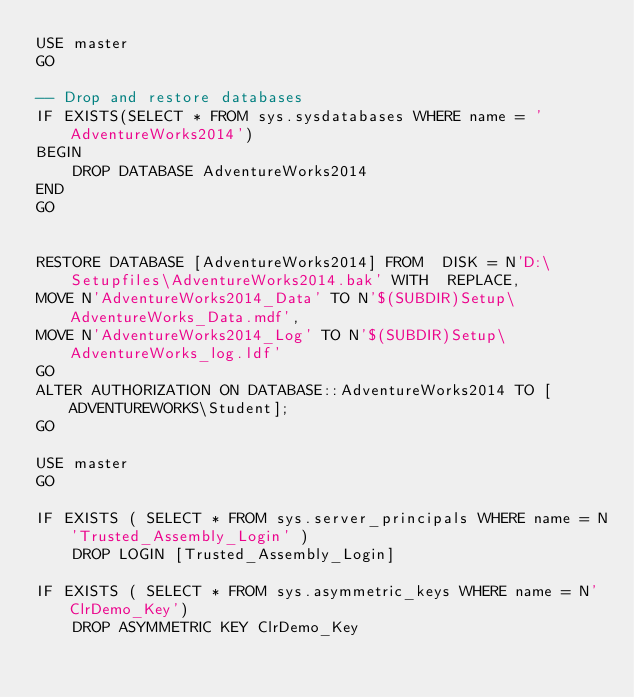Convert code to text. <code><loc_0><loc_0><loc_500><loc_500><_SQL_>USE master
GO

-- Drop and restore databases
IF EXISTS(SELECT * FROM sys.sysdatabases WHERE name = 'AdventureWorks2014')
BEGIN
	DROP DATABASE AdventureWorks2014
END
GO


RESTORE DATABASE [AdventureWorks2014] FROM  DISK = N'D:\Setupfiles\AdventureWorks2014.bak' WITH  REPLACE,
MOVE N'AdventureWorks2014_Data' TO N'$(SUBDIR)Setup\AdventureWorks_Data.mdf', 
MOVE N'AdventureWorks2014_Log' TO N'$(SUBDIR)Setup\AdventureWorks_log.ldf'
GO
ALTER AUTHORIZATION ON DATABASE::AdventureWorks2014 TO [ADVENTUREWORKS\Student];
GO

USE master
GO

IF EXISTS ( SELECT * FROM sys.server_principals WHERE name = N'Trusted_Assembly_Login' )
	DROP LOGIN [Trusted_Assembly_Login]

IF EXISTS ( SELECT * FROM sys.asymmetric_keys WHERE name = N'ClrDemo_Key')
	DROP ASYMMETRIC KEY ClrDemo_Key

</code> 